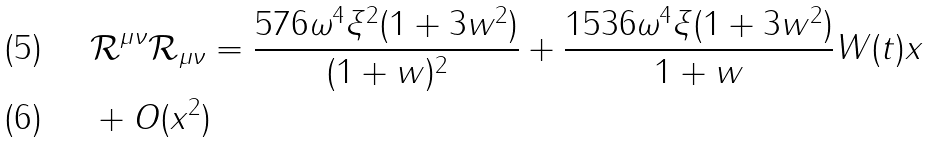Convert formula to latex. <formula><loc_0><loc_0><loc_500><loc_500>& \mathcal { R ^ { \mu \nu } R _ { \mu \nu } } = \frac { 5 7 6 \omega ^ { 4 } \xi ^ { 2 } ( 1 + 3 w ^ { 2 } ) } { ( 1 + w ) ^ { 2 } } + \frac { 1 5 3 6 \omega ^ { 4 } \xi ( 1 + 3 w ^ { 2 } ) } { 1 + w } W ( t ) x \\ & + O ( x ^ { 2 } )</formula> 